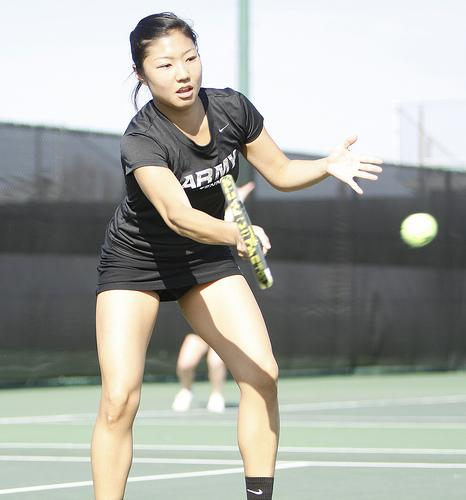Provide a brief description of the person playing tennis. The player is an Asian female with dark hair, wearing a black tennis uniform, white tennis shoes, and black Nike socks. Discuss the potential emotion of the woman and the overall sentiment of the image. The woman appears determined and focused, creating an overall sentiment of intensity and passion for the sport of tennis. How is the woman holding the tennis racket, and what is visible on her knee? The woman is holding the tennis racket with her right hand, and there is a scar visible on her right knee. How would you describe the clothing of the tennis player, and what brands are visible? The Asian female tennis player is wearing a short-sleeved black shirt with a sports logo, a black skirt, black Nike socks, and white tennis shoes. Analyze the interaction between the tennis player and the tennis ball. The tennis player is poised and ready, holding her racket in a strong grip, anticipating the airborne tennis ball, preparing to strike it with force and precision. Count and list the objects related to tennis in the image. There are 5 objects related to tennis: person ready to hit tennis ball, hand holding tennis racket, tennis ball in the air, tennis racket in a woman's hand, and green tennis ball. What is the main action happening in the image? A person is ready to hit a tennis ball in a tennis court. Identify the colors of the tennis court and ball. The tennis court is green and white, and the tennis ball is green. In a poetic language, describe the woman's facial features. Her eyes, pools of deep brown, sit beneath delicate eyebrows, while her nose and mouth express determination atop the contours of her visage. Examine the shadows in the image and describe their impact on the image quality. There is a shadow on the woman's leg, which adds depth and contrast to the image, enhancing the overall quality. 